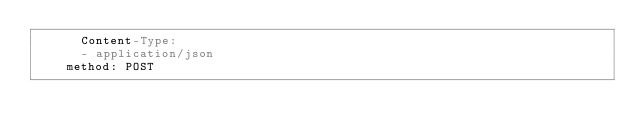Convert code to text. <code><loc_0><loc_0><loc_500><loc_500><_YAML_>      Content-Type:
      - application/json
    method: POST</code> 